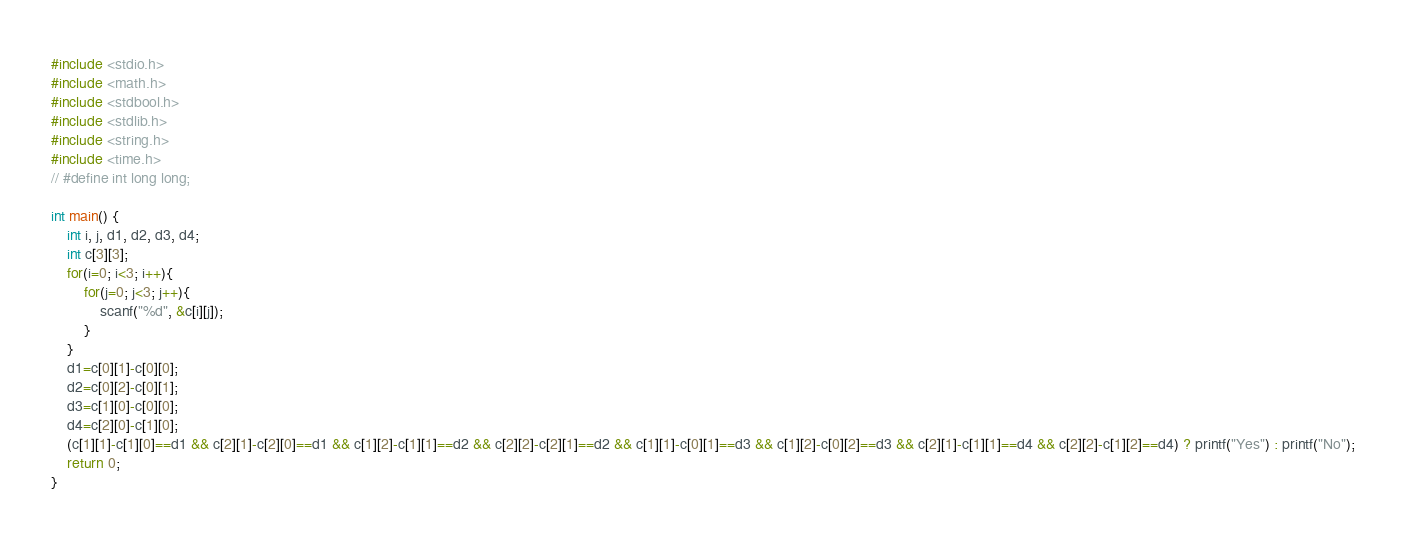Convert code to text. <code><loc_0><loc_0><loc_500><loc_500><_C_>#include <stdio.h>
#include <math.h>
#include <stdbool.h>
#include <stdlib.h>
#include <string.h>
#include <time.h>
// #define int long long;

int main() {
	int i, j, d1, d2, d3, d4;
	int c[3][3];
	for(i=0; i<3; i++){
		for(j=0; j<3; j++){
			scanf("%d", &c[i][j]);
		}
	}
	d1=c[0][1]-c[0][0];
	d2=c[0][2]-c[0][1];
	d3=c[1][0]-c[0][0];
	d4=c[2][0]-c[1][0];
	(c[1][1]-c[1][0]==d1 && c[2][1]-c[2][0]==d1 && c[1][2]-c[1][1]==d2 && c[2][2]-c[2][1]==d2 && c[1][1]-c[0][1]==d3 && c[1][2]-c[0][2]==d3 && c[2][1]-c[1][1]==d4 && c[2][2]-c[1][2]==d4) ? printf("Yes") : printf("No");
	return 0;
}</code> 